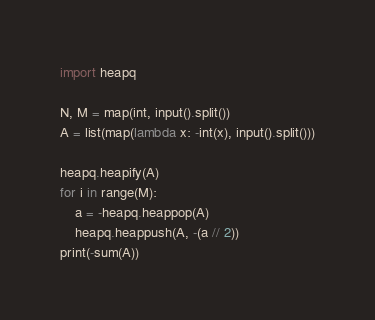Convert code to text. <code><loc_0><loc_0><loc_500><loc_500><_Python_>import heapq

N, M = map(int, input().split())
A = list(map(lambda x: -int(x), input().split()))

heapq.heapify(A)
for i in range(M):
    a = -heapq.heappop(A)
    heapq.heappush(A, -(a // 2))
print(-sum(A))
</code> 